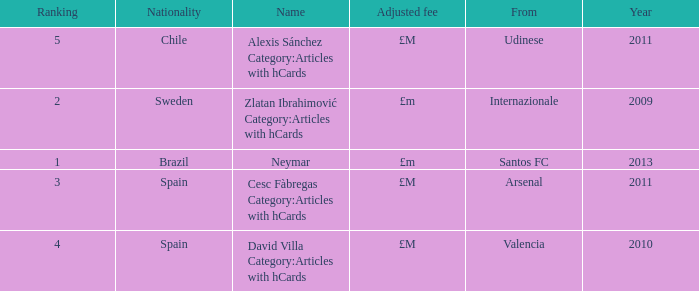What is the name of the player from Spain with a rank lower than 3? David Villa Category:Articles with hCards. 